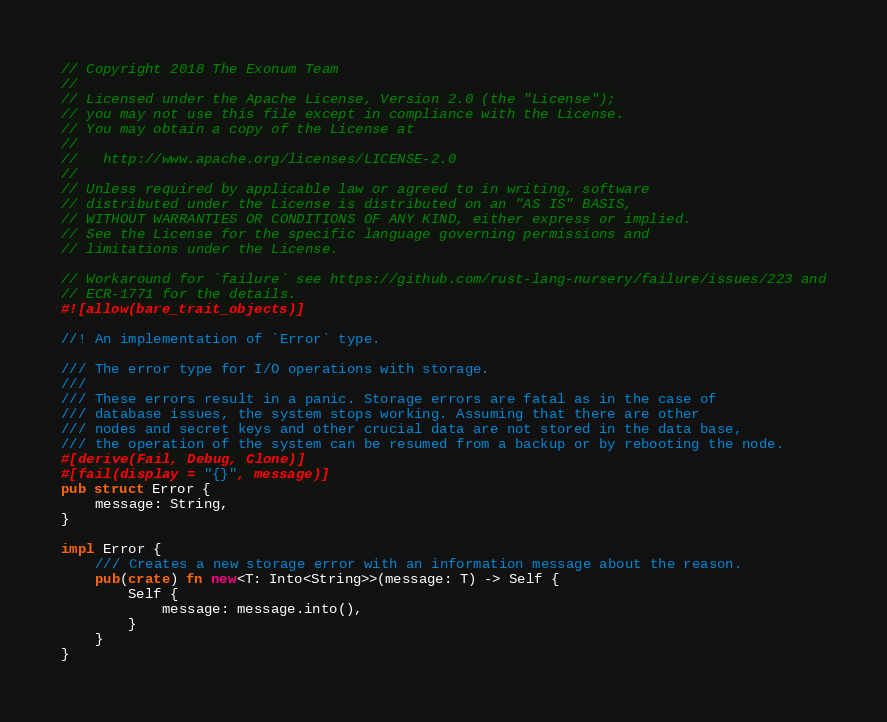Convert code to text. <code><loc_0><loc_0><loc_500><loc_500><_Rust_>// Copyright 2018 The Exonum Team
//
// Licensed under the Apache License, Version 2.0 (the "License");
// you may not use this file except in compliance with the License.
// You may obtain a copy of the License at
//
//   http://www.apache.org/licenses/LICENSE-2.0
//
// Unless required by applicable law or agreed to in writing, software
// distributed under the License is distributed on an "AS IS" BASIS,
// WITHOUT WARRANTIES OR CONDITIONS OF ANY KIND, either express or implied.
// See the License for the specific language governing permissions and
// limitations under the License.

// Workaround for `failure` see https://github.com/rust-lang-nursery/failure/issues/223 and
// ECR-1771 for the details.
#![allow(bare_trait_objects)]

//! An implementation of `Error` type.

/// The error type for I/O operations with storage.
///
/// These errors result in a panic. Storage errors are fatal as in the case of
/// database issues, the system stops working. Assuming that there are other
/// nodes and secret keys and other crucial data are not stored in the data base,
/// the operation of the system can be resumed from a backup or by rebooting the node.
#[derive(Fail, Debug, Clone)]
#[fail(display = "{}", message)]
pub struct Error {
    message: String,
}

impl Error {
    /// Creates a new storage error with an information message about the reason.
    pub(crate) fn new<T: Into<String>>(message: T) -> Self {
        Self {
            message: message.into(),
        }
    }
}
</code> 